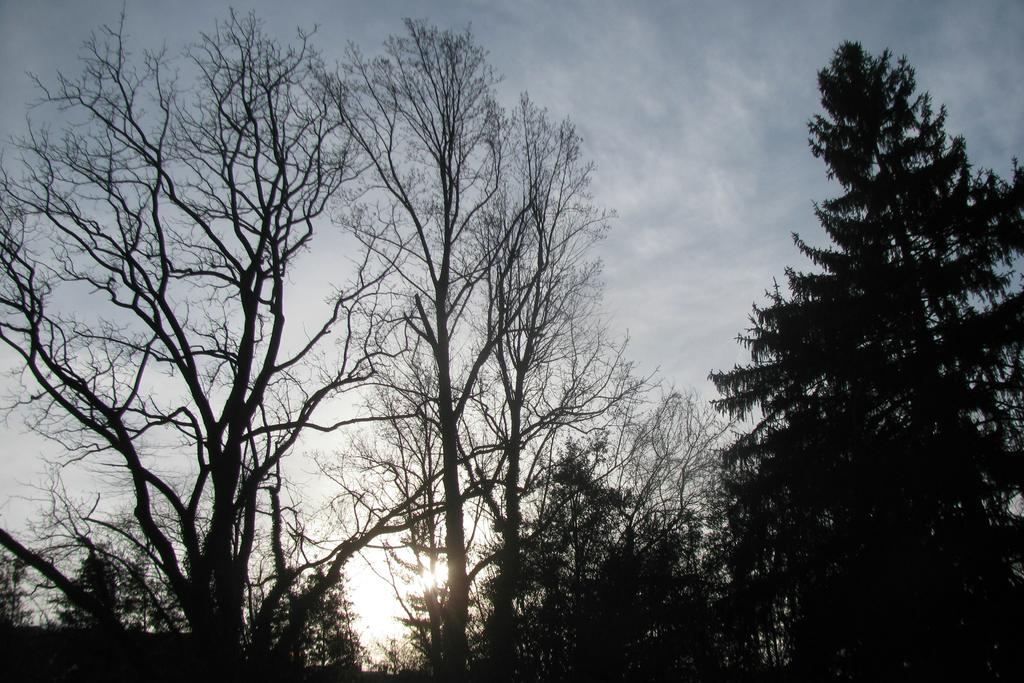What type of vegetation can be seen in the image? There are trees in the image. What part of the natural environment is visible in the image? The sky is visible in the image. What is the source of light in the image? Sunlight is present in the image. What type of calendar is hanging on the tree in the image? There is no calendar present in the image; it only features trees and the sky. How many houses can be seen in the image? There are no houses visible in the image. 